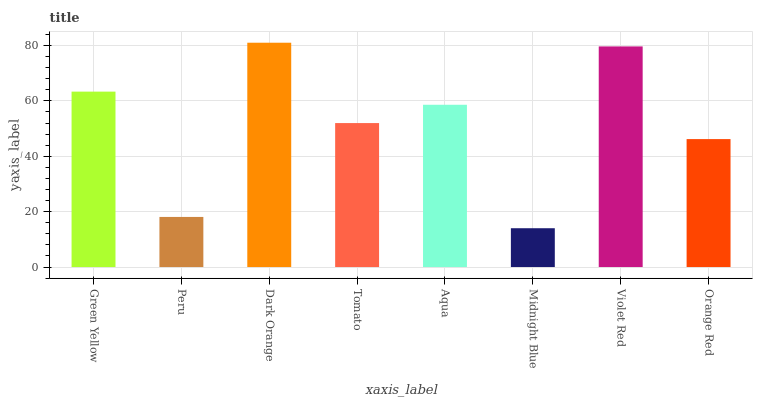Is Midnight Blue the minimum?
Answer yes or no. Yes. Is Dark Orange the maximum?
Answer yes or no. Yes. Is Peru the minimum?
Answer yes or no. No. Is Peru the maximum?
Answer yes or no. No. Is Green Yellow greater than Peru?
Answer yes or no. Yes. Is Peru less than Green Yellow?
Answer yes or no. Yes. Is Peru greater than Green Yellow?
Answer yes or no. No. Is Green Yellow less than Peru?
Answer yes or no. No. Is Aqua the high median?
Answer yes or no. Yes. Is Tomato the low median?
Answer yes or no. Yes. Is Peru the high median?
Answer yes or no. No. Is Orange Red the low median?
Answer yes or no. No. 